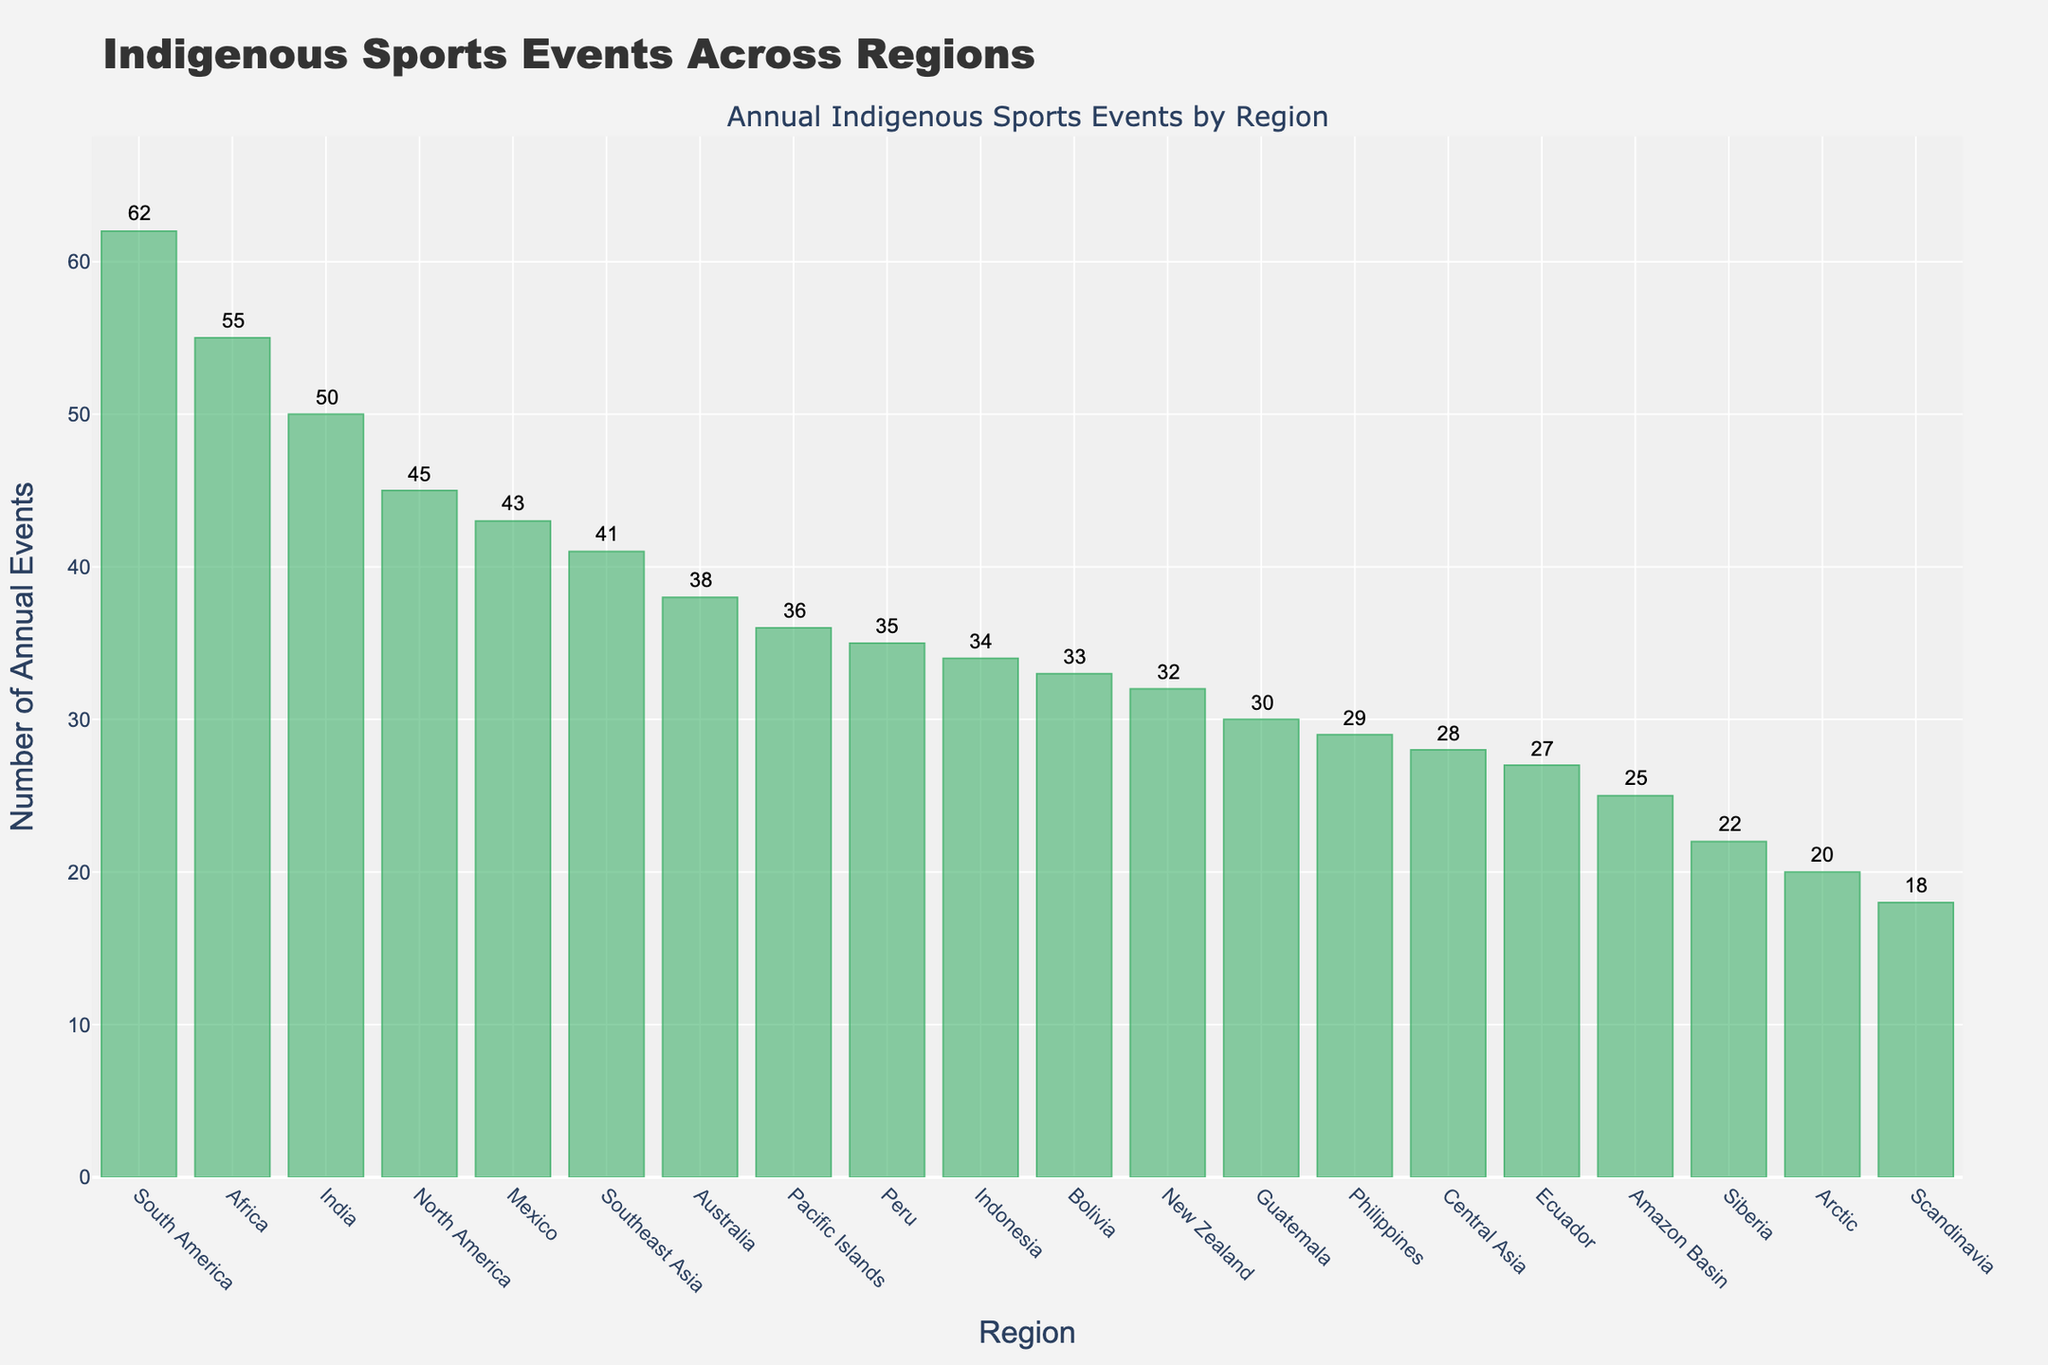what region holds the most indigenous sports events annually? By looking at the bar chart, identify the region with the tallest bar indicating the highest number of annual events. North America has the tallest bar indicating 62 events.
Answer: South America which region has fewer annual events: Arctic or Scandinavia? Compare the heights of the bars for Arctic and Scandinavia. The Arctic bar shows 20 annual events, while Scandinavia shows 18.
Answer: Scandinavia what's the sum of annual indigenous sports events held in North America, South America, and Australia? Add the number of events for these regions: 45 (North America) + 62 (South America) + 38 (Australia) = 145.
Answer: 145 what is the difference in the number of annual events held between India and the Pacific Islands? Subtract the number of events in the Pacific Islands from the number in India: 50 (India) - 36 (Pacific Islands) = 14.
Answer: 14 which two regions have the closest number of annual indigenous sports events? Look for the regions with bars of almost equal height. Mexico (43) and North America (45) are the closest, with a difference of only 2 events.
Answer: Mexico and North America how many regions have more than 30 annual indigenous sports events? Count the bars that indicate more than 30 events. There are ten regions: North America, South America, Australia, New Zealand, Africa, Southeast Asia, India, Mexico, Peru, and Bolivia.
Answer: Ten what's the average number of annual events across all regions shown in the plot? Adding up all the events gives 714. There are 19 regions, so the average is 714/19 ≈ 37.58.
Answer: 37.58 is the bar for Southeast Asia taller or shorter than the bar for Indonesia? Compare visually the heights of the bars for Southeast Asia and Indonesia. Southeast Asia's bar (41) is taller than Indonesia's bar (34).
Answer: Taller what regions have fewer than 30 annual indigenous sports events? Identify the regions with bars indicating fewer than 30 events: Central Asia (28), Arctic (20), Amazon Basin (25), Scandinavia (18), Siberia (22), Philippines (29), Ecuador (27).
Answer: Seven 